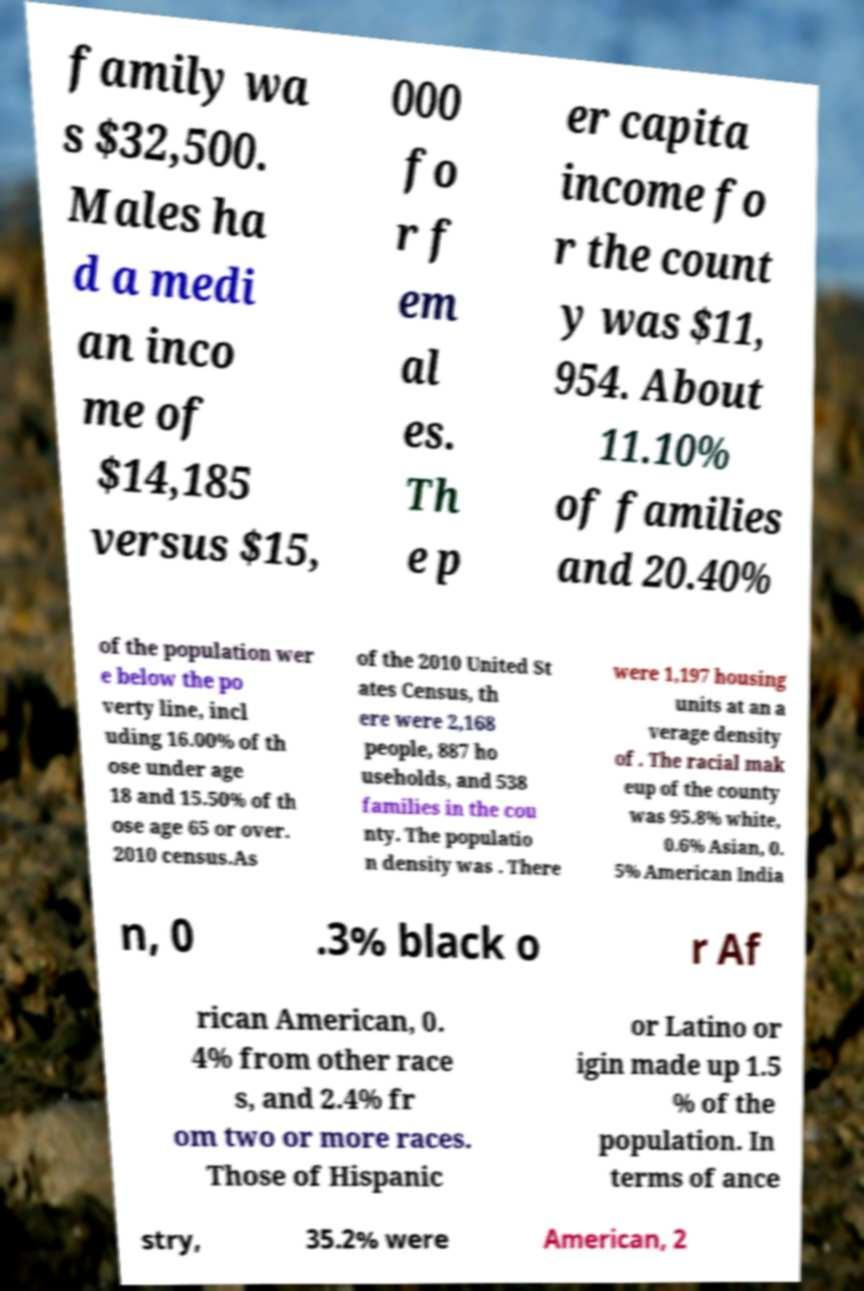Could you extract and type out the text from this image? family wa s $32,500. Males ha d a medi an inco me of $14,185 versus $15, 000 fo r f em al es. Th e p er capita income fo r the count y was $11, 954. About 11.10% of families and 20.40% of the population wer e below the po verty line, incl uding 16.00% of th ose under age 18 and 15.50% of th ose age 65 or over. 2010 census.As of the 2010 United St ates Census, th ere were 2,168 people, 887 ho useholds, and 538 families in the cou nty. The populatio n density was . There were 1,197 housing units at an a verage density of . The racial mak eup of the county was 95.8% white, 0.6% Asian, 0. 5% American India n, 0 .3% black o r Af rican American, 0. 4% from other race s, and 2.4% fr om two or more races. Those of Hispanic or Latino or igin made up 1.5 % of the population. In terms of ance stry, 35.2% were American, 2 